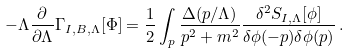<formula> <loc_0><loc_0><loc_500><loc_500>- \Lambda \frac { \partial } { \partial \Lambda } \Gamma _ { I , B , \Lambda } [ \Phi ] = \frac { 1 } { 2 } \int _ { p } \frac { \Delta ( p / \Lambda ) } { p ^ { 2 } + m ^ { 2 } } \frac { \delta ^ { 2 } S _ { I , \Lambda } [ \phi ] } { \delta \phi ( - p ) \delta \phi ( p ) } \, .</formula> 